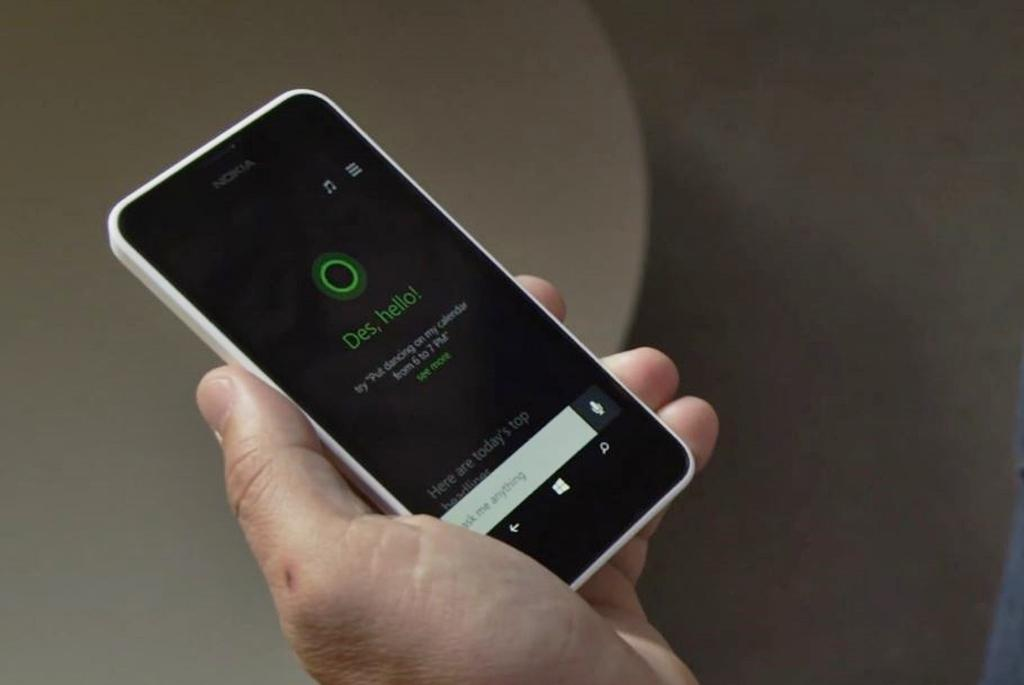<image>
Summarize the visual content of the image. A man holding a nokia smart phone with Des, hello! displayed on the screen. 